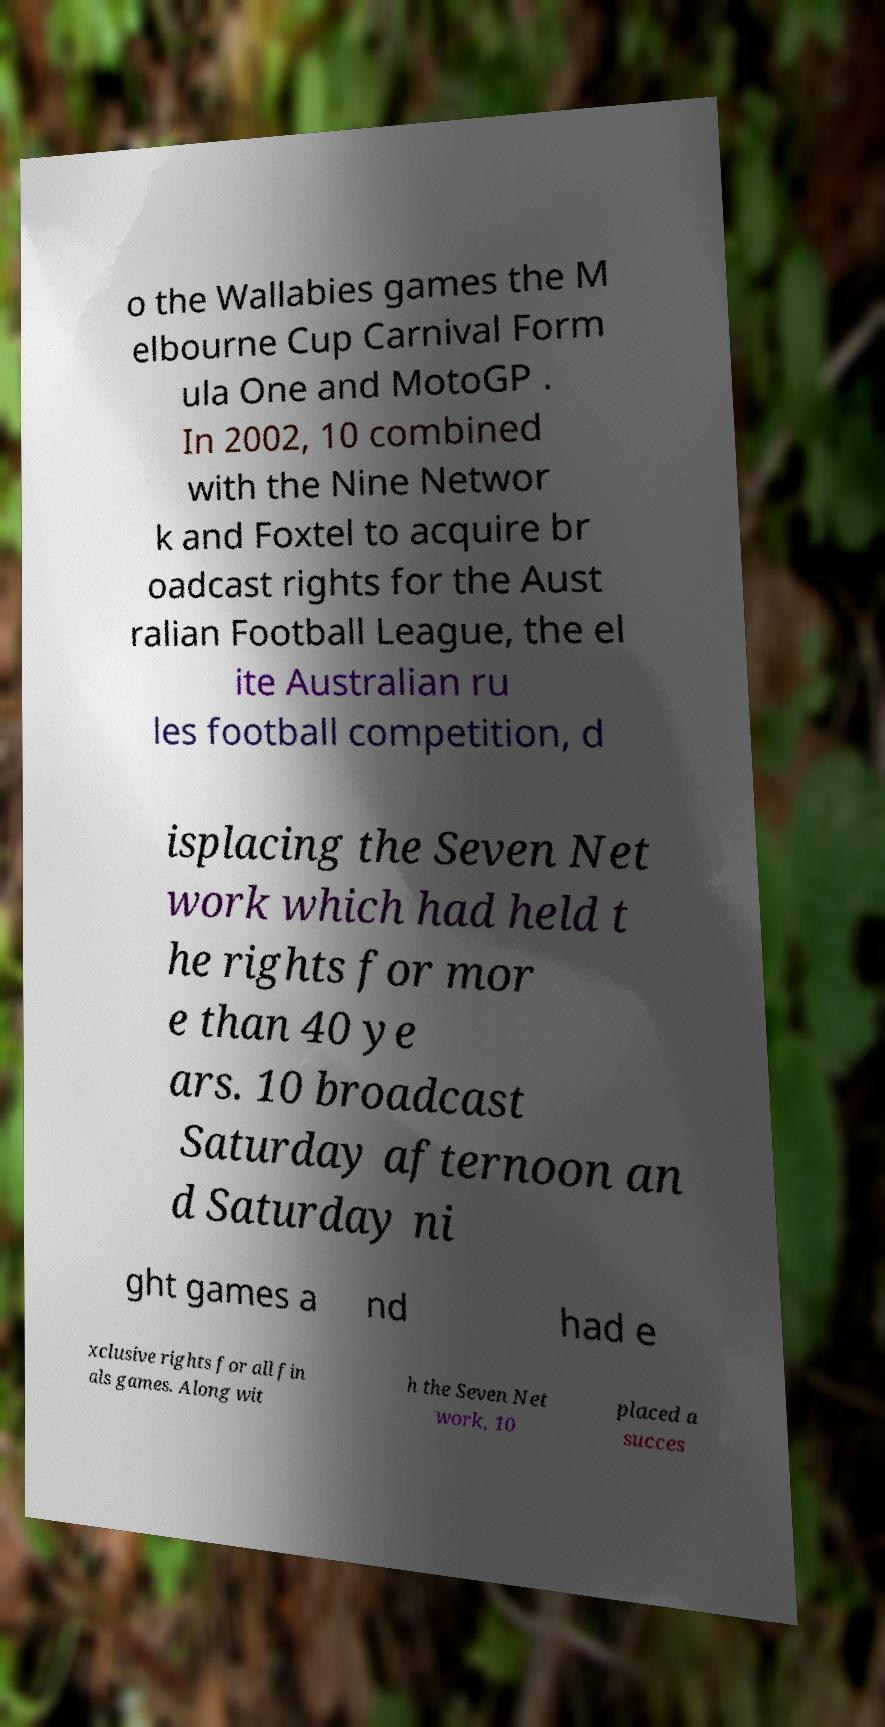I need the written content from this picture converted into text. Can you do that? o the Wallabies games the M elbourne Cup Carnival Form ula One and MotoGP . In 2002, 10 combined with the Nine Networ k and Foxtel to acquire br oadcast rights for the Aust ralian Football League, the el ite Australian ru les football competition, d isplacing the Seven Net work which had held t he rights for mor e than 40 ye ars. 10 broadcast Saturday afternoon an d Saturday ni ght games a nd had e xclusive rights for all fin als games. Along wit h the Seven Net work, 10 placed a succes 